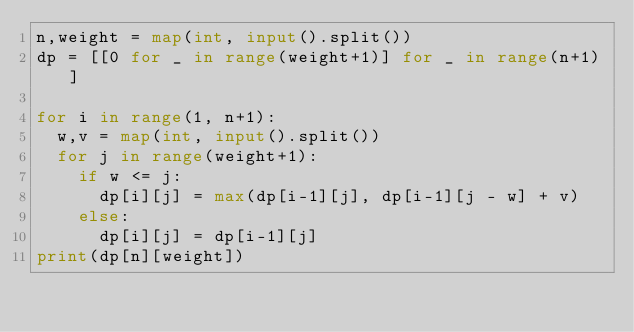Convert code to text. <code><loc_0><loc_0><loc_500><loc_500><_Python_>n,weight = map(int, input().split())
dp = [[0 for _ in range(weight+1)] for _ in range(n+1)]

for i in range(1, n+1):
  w,v = map(int, input().split())
  for j in range(weight+1):
    if w <= j:
      dp[i][j] = max(dp[i-1][j], dp[i-1][j - w] + v)
    else:
      dp[i][j] = dp[i-1][j]
print(dp[n][weight])
</code> 